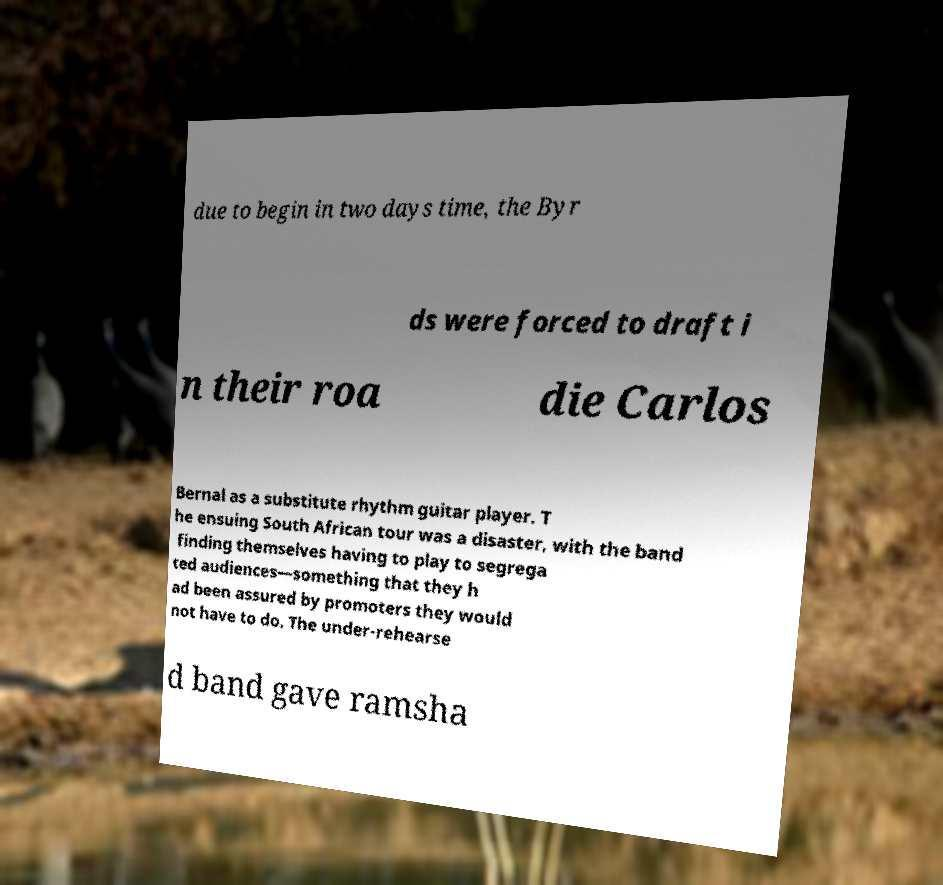For documentation purposes, I need the text within this image transcribed. Could you provide that? due to begin in two days time, the Byr ds were forced to draft i n their roa die Carlos Bernal as a substitute rhythm guitar player. T he ensuing South African tour was a disaster, with the band finding themselves having to play to segrega ted audiences—something that they h ad been assured by promoters they would not have to do. The under-rehearse d band gave ramsha 